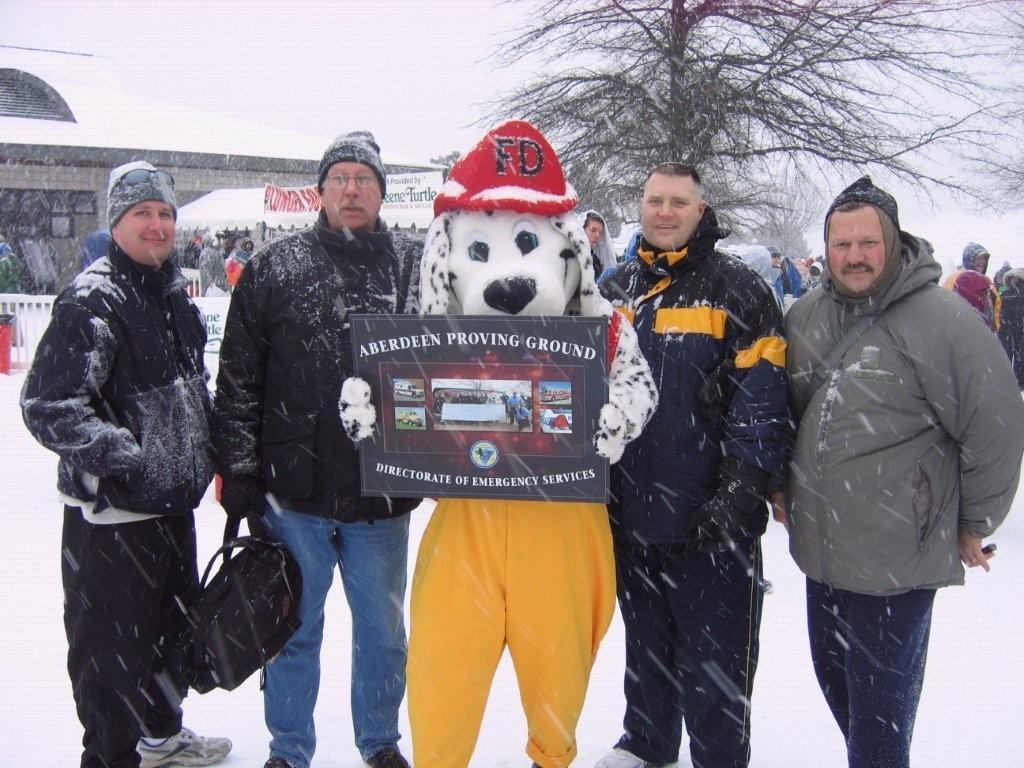In one or two sentences, can you explain what this image depicts? This picture describes about group of people, they are standing on the ice, in the middle of the given image we can see a person wore costumes and holding a paper, in the background we can see trees, buildings and tents. 